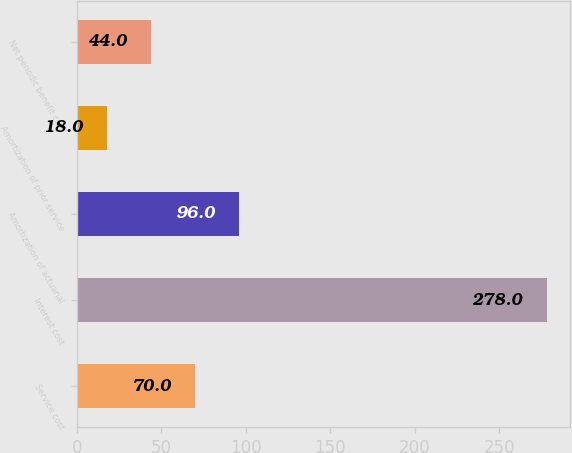Convert chart. <chart><loc_0><loc_0><loc_500><loc_500><bar_chart><fcel>Service cost<fcel>Interest cost<fcel>Amortization of actuarial<fcel>Amortization of prior service<fcel>Net periodic benefit cost<nl><fcel>70<fcel>278<fcel>96<fcel>18<fcel>44<nl></chart> 